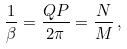<formula> <loc_0><loc_0><loc_500><loc_500>\frac { 1 } { \beta } = \frac { Q P } { 2 \pi } = \frac { N } { M } \, ,</formula> 